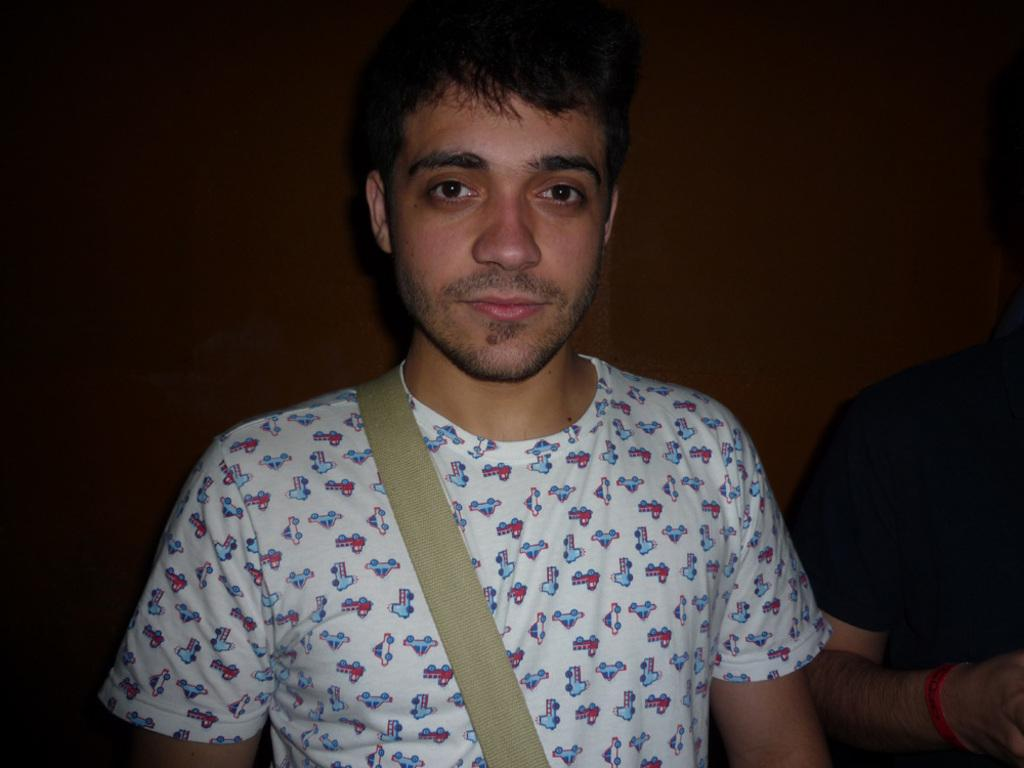How many people are present in the image? There are two people in the image. What colors are the shirts of the people in the image? One person is wearing a white shirt, and the other person is wearing a black shirt. What can be seen in the background of the image? There is a wall in the background of the image. Can you hear the chickens laughing in the image? There are no chickens or sounds present in the image, so it is not possible to hear them laughing. 